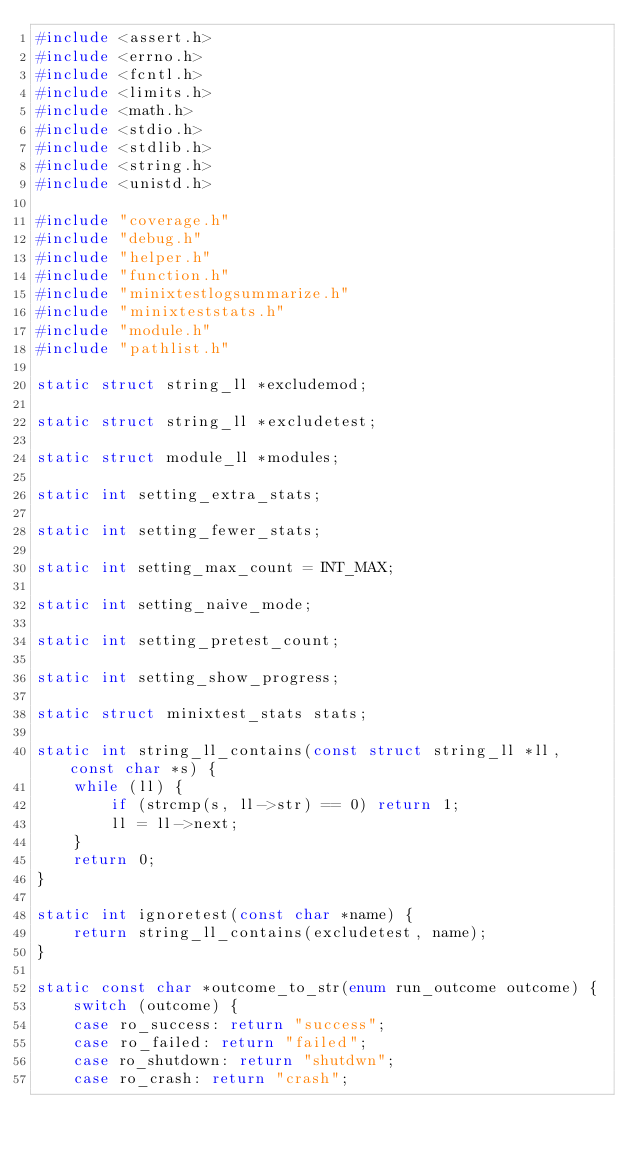Convert code to text. <code><loc_0><loc_0><loc_500><loc_500><_C_>#include <assert.h>
#include <errno.h>
#include <fcntl.h>
#include <limits.h>
#include <math.h>
#include <stdio.h>
#include <stdlib.h>
#include <string.h>
#include <unistd.h>

#include "coverage.h"
#include "debug.h"
#include "helper.h"
#include "function.h"
#include "minixtestlogsummarize.h"
#include "minixteststats.h"
#include "module.h"
#include "pathlist.h"

static struct string_ll *excludemod;

static struct string_ll *excludetest;

static struct module_ll *modules;

static int setting_extra_stats;

static int setting_fewer_stats;

static int setting_max_count = INT_MAX;

static int setting_naive_mode;

static int setting_pretest_count;

static int setting_show_progress;

static struct minixtest_stats stats;

static int string_ll_contains(const struct string_ll *ll, const char *s) {
	while (ll) {
		if (strcmp(s, ll->str) == 0) return 1;
		ll = ll->next;
	}
	return 0;
}

static int ignoretest(const char *name) {
	return string_ll_contains(excludetest, name);
}

static const char *outcome_to_str(enum run_outcome outcome) {
	switch (outcome) {
	case ro_success: return "success";
	case ro_failed: return "failed";
	case ro_shutdown: return "shutdwn";
	case ro_crash: return "crash";</code> 